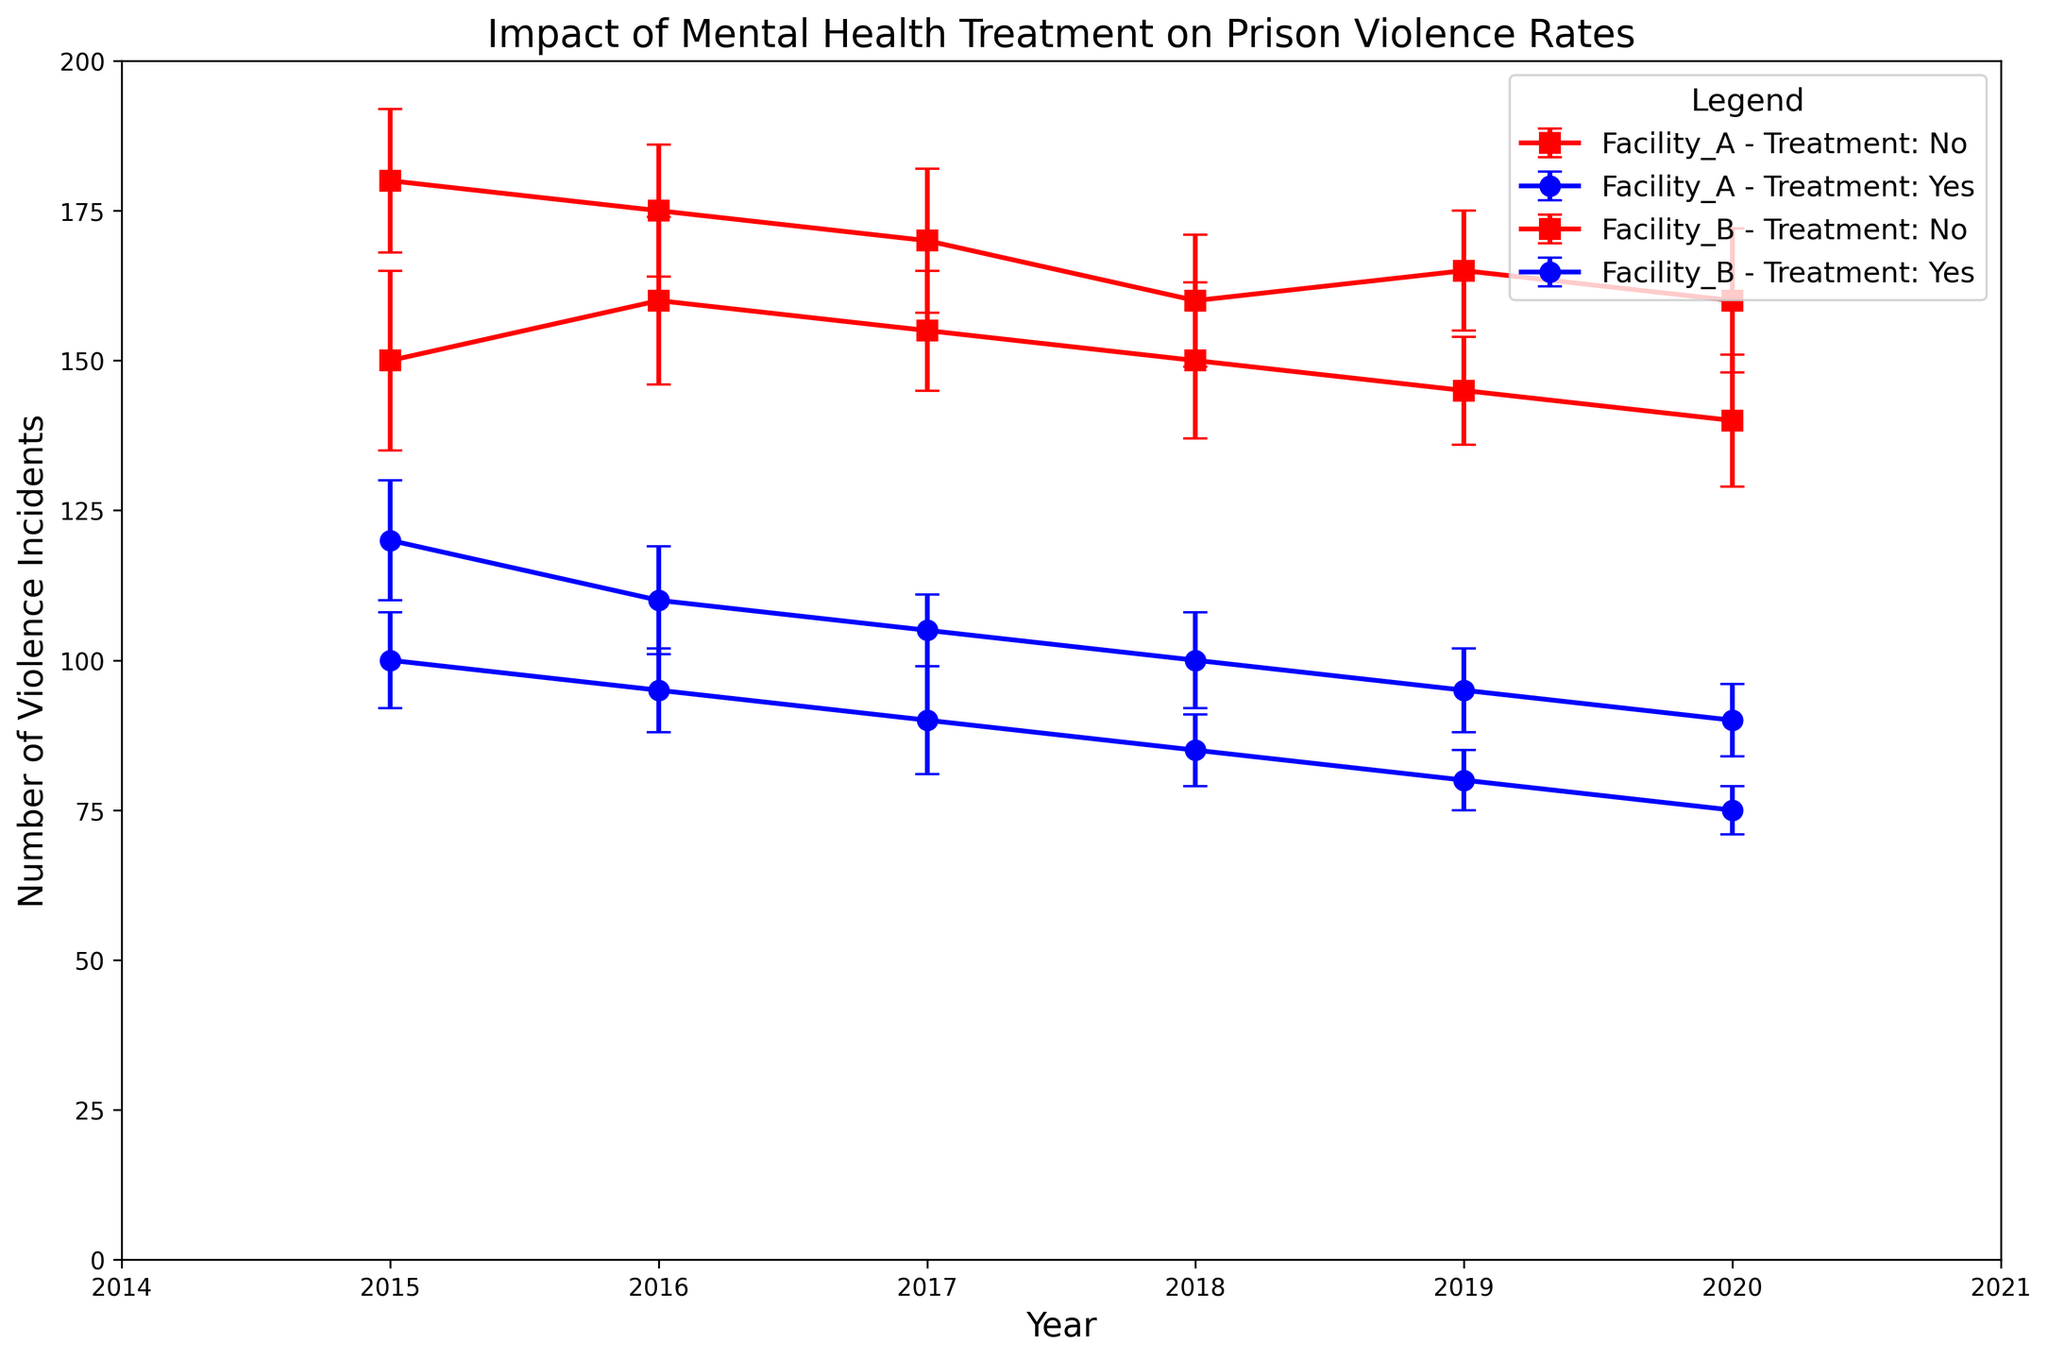How did the violence incidents in Facility A change from 2015 to 2020 for those receiving mental health treatment? To answer this, observe the data points for Facility A with mental health treatment from 2015 (120 incidents) to 2020 (90 incidents). The change is calculated by subtracting the incidents in 2020 from the incidents in 2015: 120 - 90 = 30. Thus, violence incidents decreased by 30.
Answer: Decreased by 30 How much higher were violence incidents in Facility B without mental health treatment compared to Facility A without mental health treatment in 2015? In 2015, Facility B without treatment had 150 incidents, and Facility A without treatment had 180 incidents. The difference is calculated by subtracting Facility B's incidents from Facility A's incidents: 180 - 150 = 30. Thus, Facility A had 30 more incidents.
Answer: 30 more in Facility A In which year did Facility B see the lowest number of violence incidents with mental health treatment, and how many incidents were reported? Check the data points for Facility B with mental health treatment across the years. The lowest value is 75 incidents in 2020.
Answer: 2020, 75 incidents What is the average number of violence incidents in Facility A without mental health treatment from 2015 to 2020? The incidents reported from 2015 to 2020 in Facility A without treatment are 180, 175, 170, 160, 165, and 160. Sum these values: 180 + 175 + 170 + 160 + 165 + 160 = 1010. There are 6 years, so divide the sum by 6: 1010 / 6 ≈ 168.33.
Answer: Approximately 168.33 Compare the trend of violence incidents for Facility A with and without mental health treatment from 2015 to 2020. Facility A with treatment shows a decreasing trend from 120 incidents in 2015 to 90 incidents in 2020. Without treatment, the incidents decrease slightly, from 180 in 2015 to 160 in 2020, but with more variation. Thus, the trend for those with treatment is a clearer decrease compared to a moderate decrease without treatment.
Answer: Decrease for both, clearer with treatment Between Facility A and Facility B, which facility had a smaller variation in violence incidents for those with mental health treatment from 2015 to 2020, as shown by the error bars? Compare the length of the error bars for mental health treatment in both facilities from 2015 to 2020. Facility A generally shows smaller error bars compared to Facility B, indicating less variation in reported incidents.
Answer: Facility A 